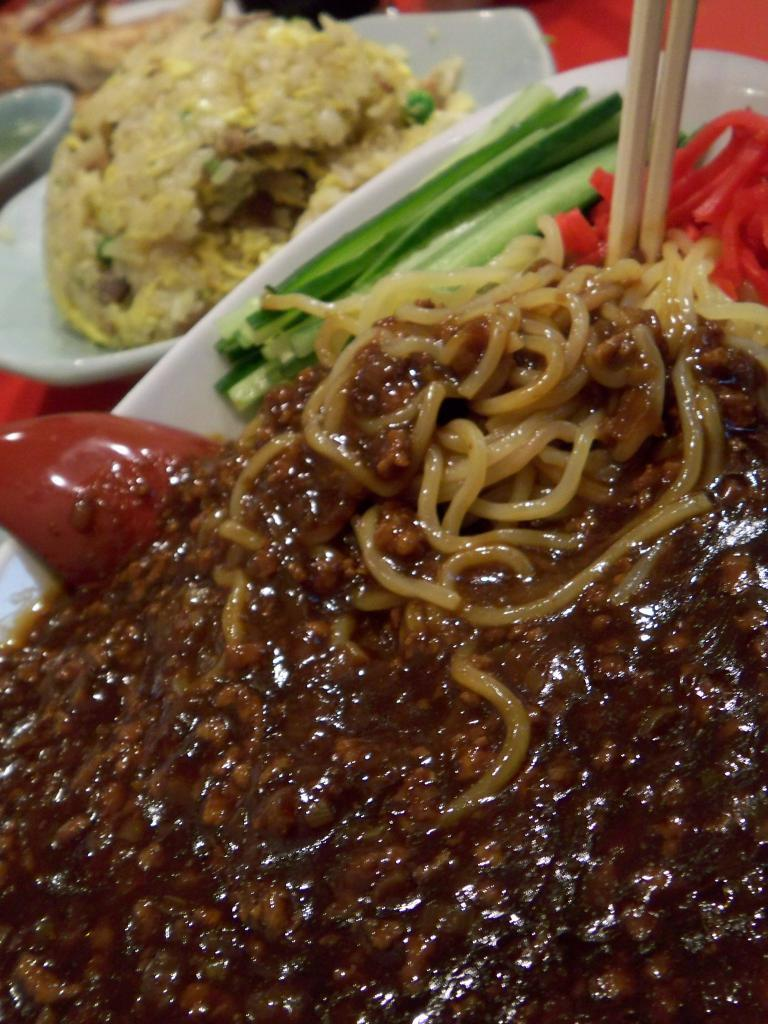What type of utensils can be seen in the image? Chopsticks are visible in the image. What is the color of the plate that holds the food items? The food items are on a white color plate in the image. Can you describe the background of the image? The background of the image is slightly blurred. How many people are swimming in the image? There is no indication of swimming or people in the image; it features food items and chopsticks on a white plate with a slightly blurred background. 